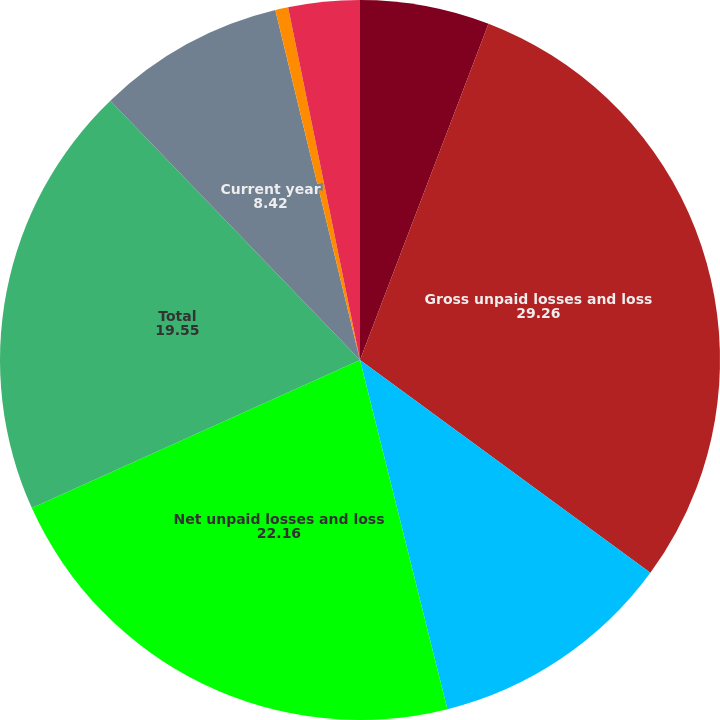Convert chart to OTSL. <chart><loc_0><loc_0><loc_500><loc_500><pie_chart><fcel>(in millions of US dollars)<fcel>Gross unpaid losses and loss<fcel>Reinsurance recoverable on<fcel>Net unpaid losses and loss<fcel>Total<fcel>Current year<fcel>Prior years<fcel>Foreign currency revaluation<nl><fcel>5.81%<fcel>29.26%<fcel>11.03%<fcel>22.16%<fcel>19.55%<fcel>8.42%<fcel>0.58%<fcel>3.2%<nl></chart> 